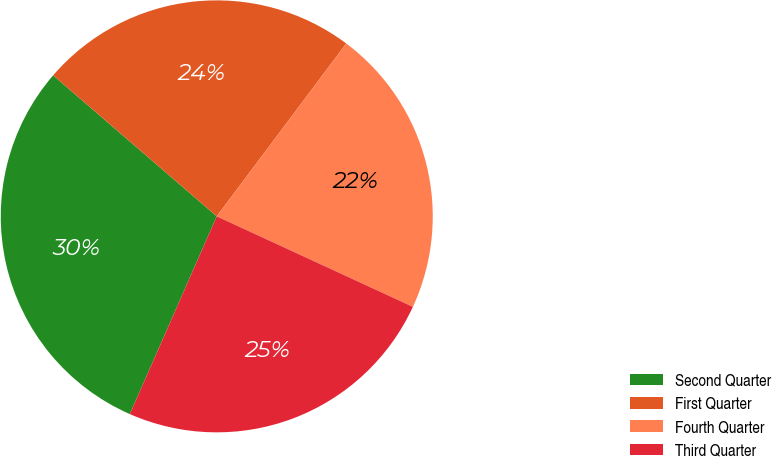Convert chart. <chart><loc_0><loc_0><loc_500><loc_500><pie_chart><fcel>Second Quarter<fcel>First Quarter<fcel>Fourth Quarter<fcel>Third Quarter<nl><fcel>29.73%<fcel>23.91%<fcel>21.65%<fcel>24.71%<nl></chart> 